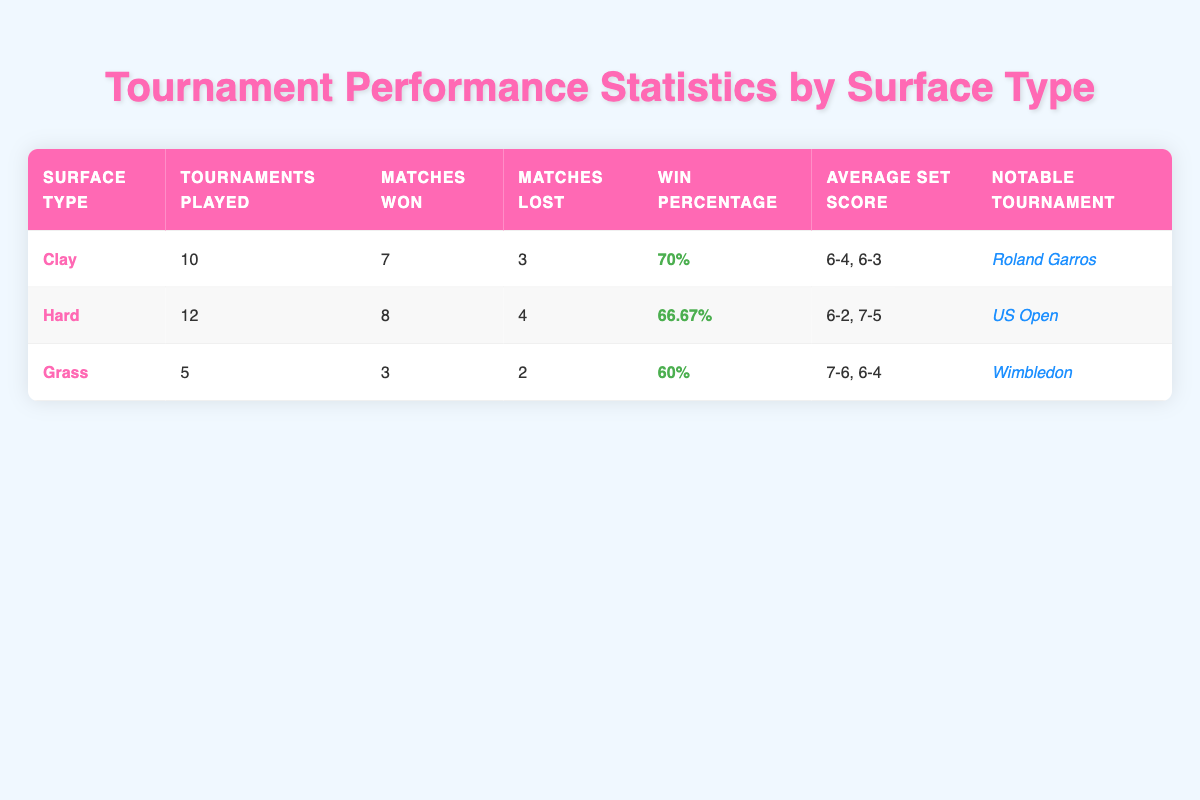What is the win percentage for Clay surface tournaments? The table states the win percentage for Clay surface tournaments is identified under the "Win Percentage" column. For Clay, it shows 70%.
Answer: 70% Which notable tournament is associated with Grass surface performance? The table indicates under the "Notable Tournament" column for Grass that the notable tournament is Wimbledon.
Answer: Wimbledon How many matches were won on Hard courts? The total matches won on Hard courts can be found in the "Matches Won" column for the Hard surface. It indicates that 8 matches were won.
Answer: 8 What is the average number of tournaments played across all surfaces? To find the average number of tournaments played, we must sum the tournaments played for all surfaces (10 for Clay, 12 for Hard, and 5 for Grass) which is 10 + 12 + 5 = 27. Then, divide by the number of surface types, which is 3. Therefore, 27/3 = 9.
Answer: 9 Is the win percentage on Grass higher than on Clay? The win percentage for Grass is 60% and for Clay is 70%. Since 60% is not higher than 70%, the statement is false.
Answer: No What is the difference in matches lost between Hard courts and Clay courts? The matches lost on Hard courts is found in the "Matches Lost" column, which shows 4, while Clay courts shows 3 matches lost. The difference is calculated by subtracting the matches lost on Clay from those lost on Hard: 4 - 3 = 1.
Answer: 1 Which surface type has the lowest win percentage? By comparing the win percentages listed in the table: Clay has 70%, Hard has 66.67%, and Grass has 60%. The Grass surface has the lowest win percentage of 60%.
Answer: Grass How many total matches did you win on all surfaces combined? To find the total matches won across all surfaces, we sum the matches won: 7 for Clay, 8 for Hard, and 3 for Grass. Therefore, 7 + 8 + 3 = 18.
Answer: 18 How many more tournaments have been played on Hard than on Grass? Looking at the "Tournaments Played" column, Hard shows 12 tournaments played and Grass shows 5. The difference can be found by subtracting the tournaments on Grass from those on Hard: 12 - 5 = 7.
Answer: 7 